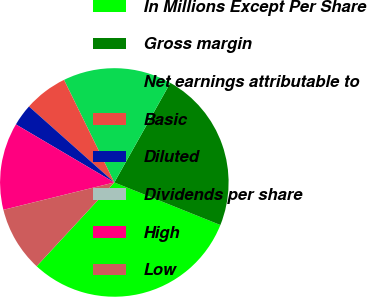<chart> <loc_0><loc_0><loc_500><loc_500><pie_chart><fcel>In Millions Except Per Share<fcel>Gross margin<fcel>Net earnings attributable to<fcel>Basic<fcel>Diluted<fcel>Dividends per share<fcel>High<fcel>Low<nl><fcel>30.82%<fcel>22.92%<fcel>15.41%<fcel>6.17%<fcel>3.09%<fcel>0.0%<fcel>12.33%<fcel>9.25%<nl></chart> 